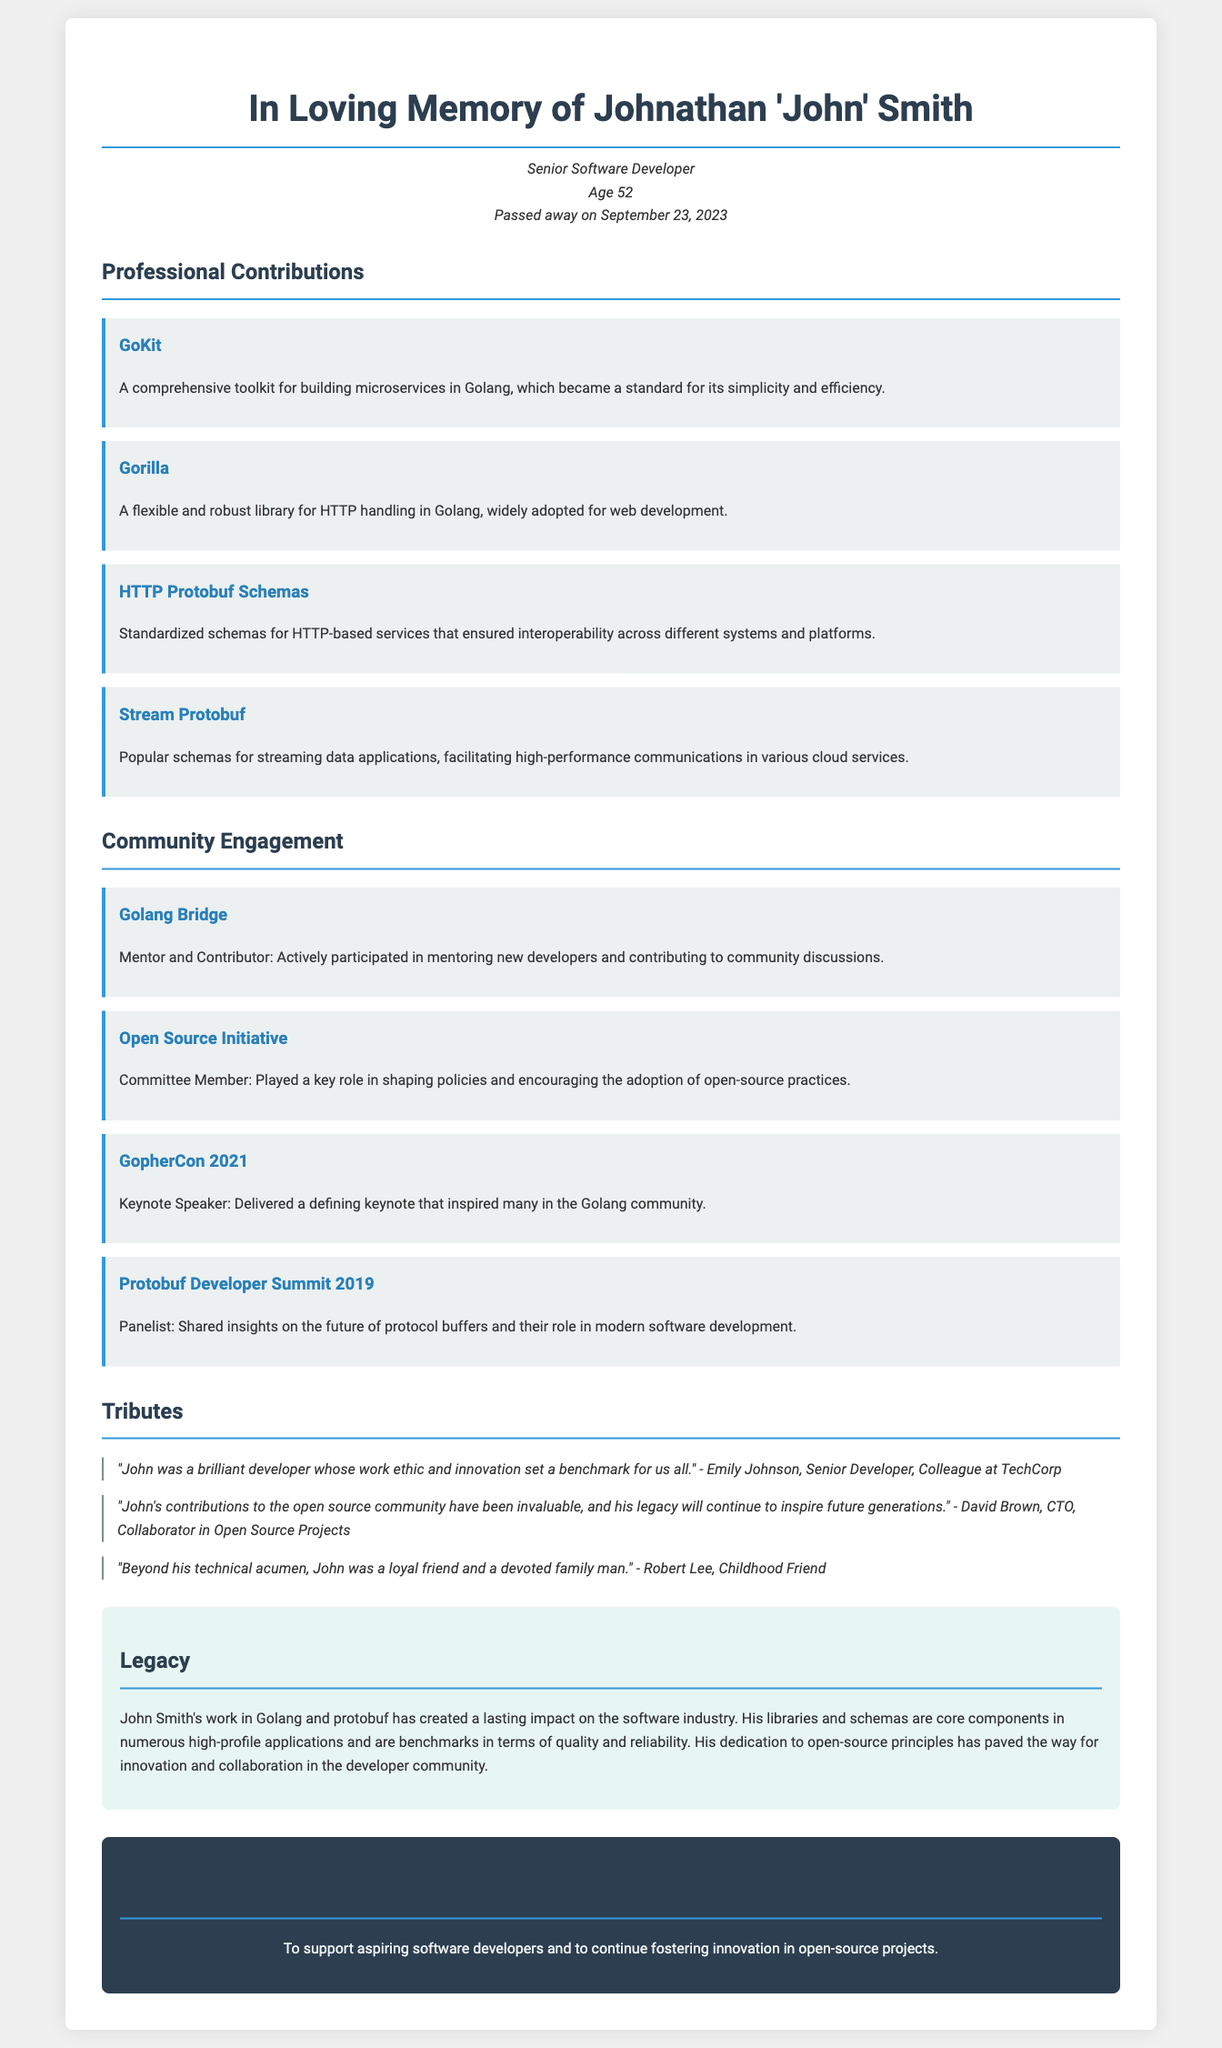What was Johnathan Smith's age at the time of passing? The document states that Johnathan 'John' Smith was 52 years old when he passed away.
Answer: 52 What significant role did John Smith play in the Golang community? The document mentions his role as a mentor in the Golang Bridge and as a contributor to community discussions, indicating his significance in the community.
Answer: Mentor What was the name of the memorial fund established in John Smith's honor? The document clearly states the name of the memorial fund as the "John Smith Memorial Fund."
Answer: John Smith Memorial Fund Which major event did John Smith keynote in 2021? The document specifies that he was a keynote speaker at GopherCon 2021.
Answer: GopherCon 2021 What year did John Smith pass away? The document explicitly mentions the date of his passing as September 23, 2023.
Answer: September 23, 2023 What was the main focus of the HTTP Protobuf Schemas John Smith contributed to? The document describes the schemas as ensuring interoperability across different systems and platforms, indicating their focus on compatibility.
Answer: Interoperability Name one of the libraries authored by John Smith that became a standard for Golang microservices. The document lists GoKit as a comprehensive toolkit for building microservices in Golang that became a standard.
Answer: GoKit Which organization was John Smith part of that influenced open-source practices? The document identifies him as a Committee Member of the Open Source Initiative, indicating his involvement in shaping policies for open-source practices.
Answer: Open Source Initiative What kind of impact did John Smith's work have on the software industry? The document states that his work has created a lasting impact, emphasizing the quality and reliability of his contributions in high-profile applications.
Answer: Lasting impact 